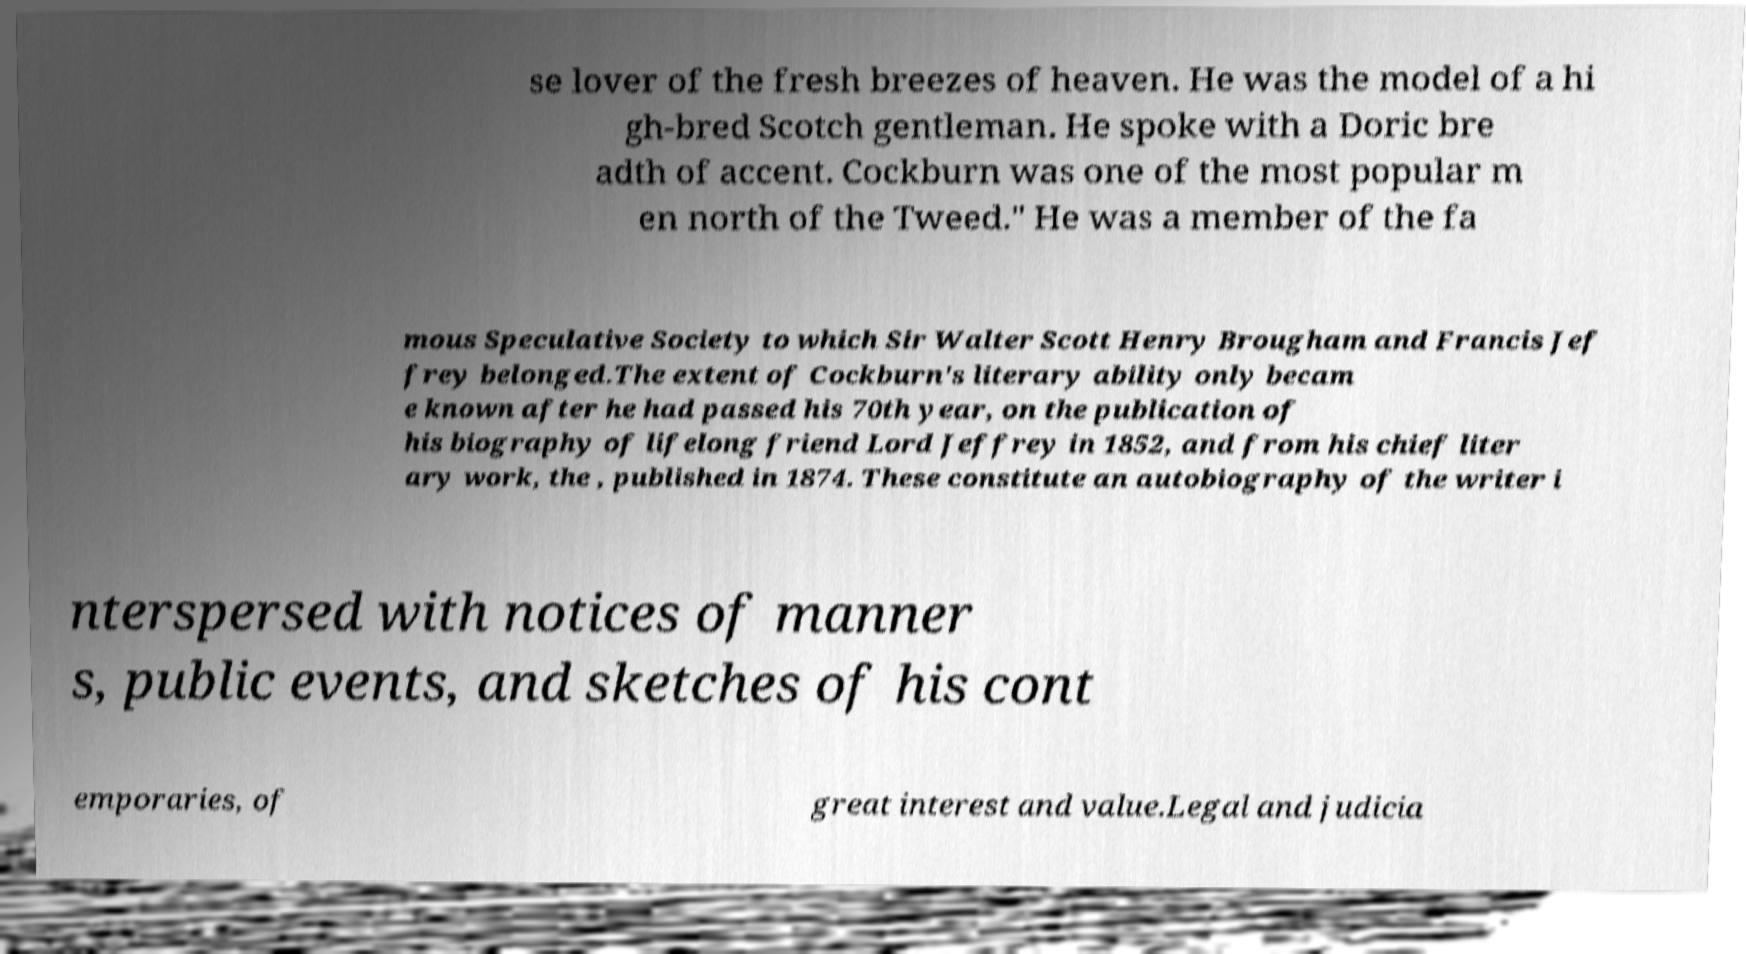Can you accurately transcribe the text from the provided image for me? se lover of the fresh breezes of heaven. He was the model of a hi gh-bred Scotch gentleman. He spoke with a Doric bre adth of accent. Cockburn was one of the most popular m en north of the Tweed." He was a member of the fa mous Speculative Society to which Sir Walter Scott Henry Brougham and Francis Jef frey belonged.The extent of Cockburn's literary ability only becam e known after he had passed his 70th year, on the publication of his biography of lifelong friend Lord Jeffrey in 1852, and from his chief liter ary work, the , published in 1874. These constitute an autobiography of the writer i nterspersed with notices of manner s, public events, and sketches of his cont emporaries, of great interest and value.Legal and judicia 